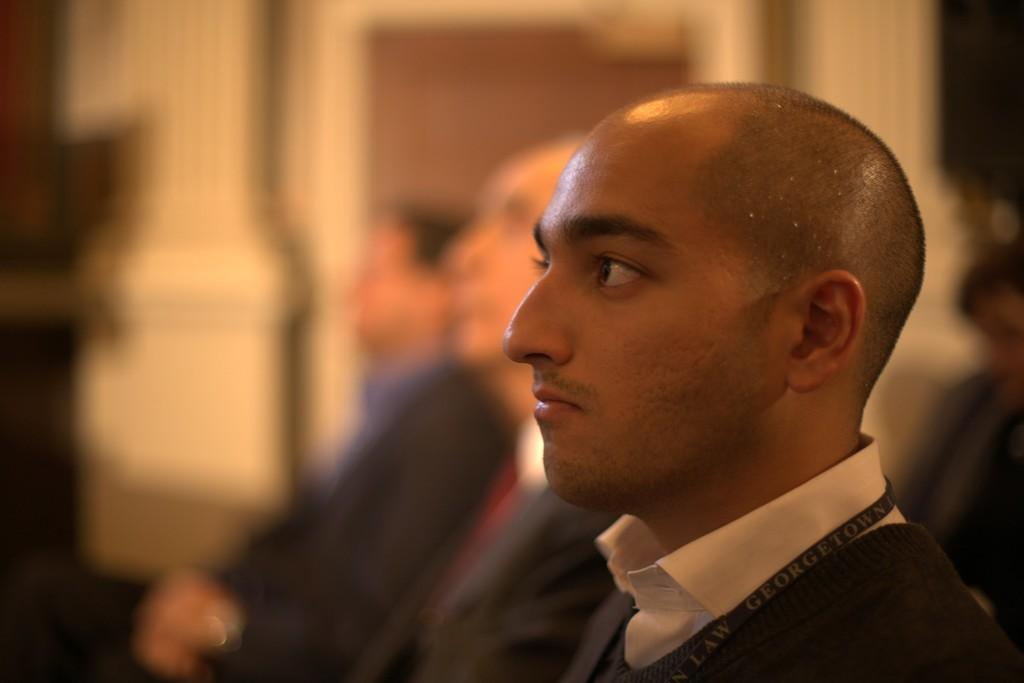Who is present in the image? There is a man in the image. What is the man wearing? The man is wearing a shirt and a sweater. Can you describe any additional details about the image? There is a tag in the image, and there are two people sitting. How would you describe the background of the image? The background of the image appears blurry. What type of thread is being used by the man in the image? There is no indication in the image that the man is using any thread. 